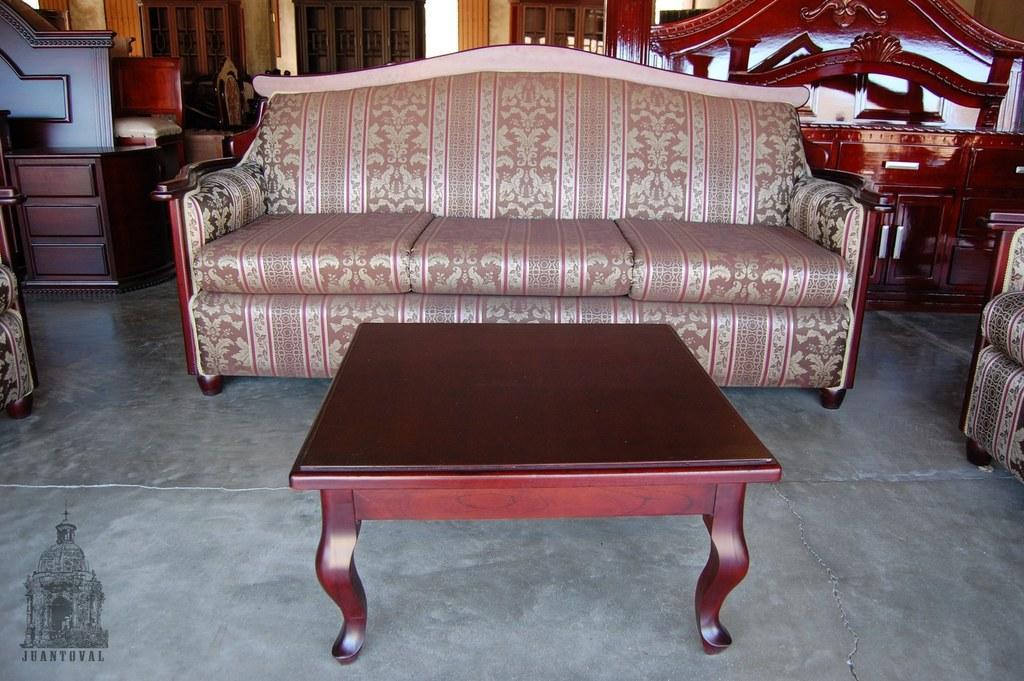Can you describe this image briefly? There is a sofa which is light pink in color and there is a table in front of it and in background there are many furnitures. 